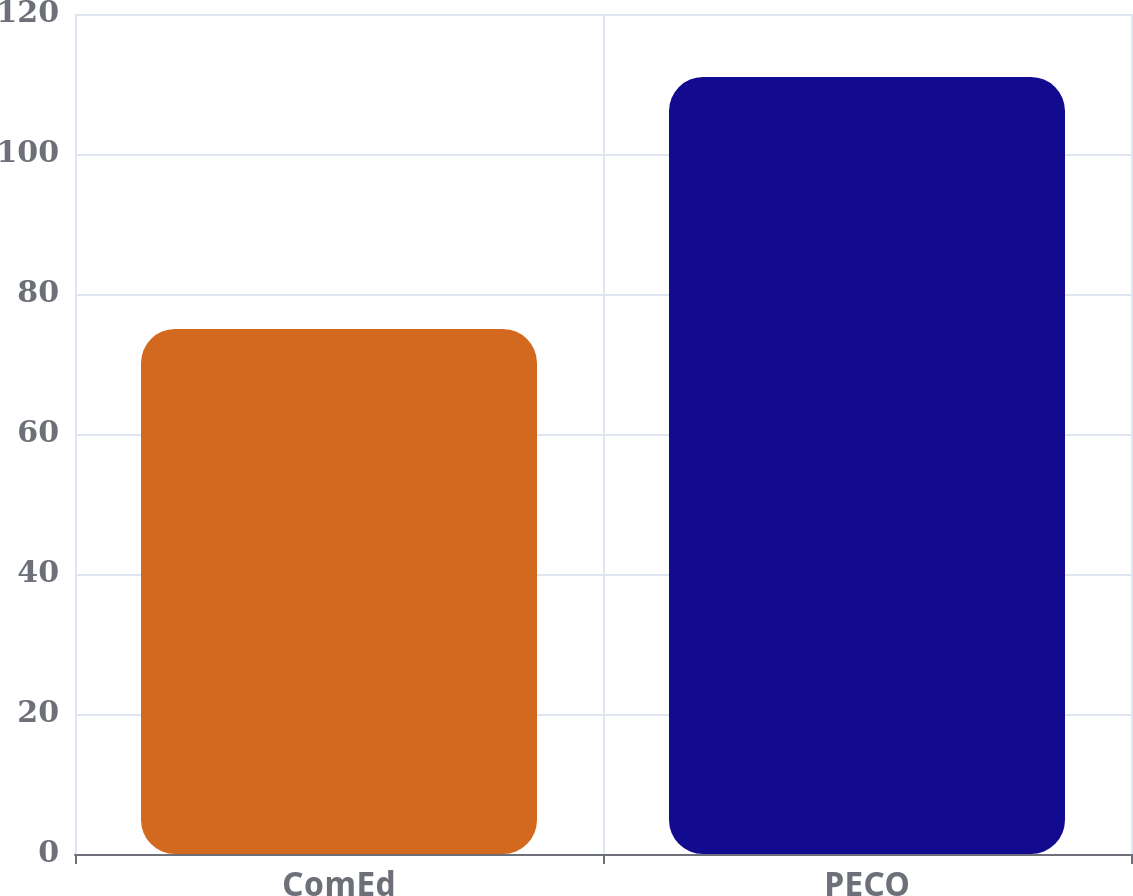Convert chart. <chart><loc_0><loc_0><loc_500><loc_500><bar_chart><fcel>ComEd<fcel>PECO<nl><fcel>75<fcel>111<nl></chart> 